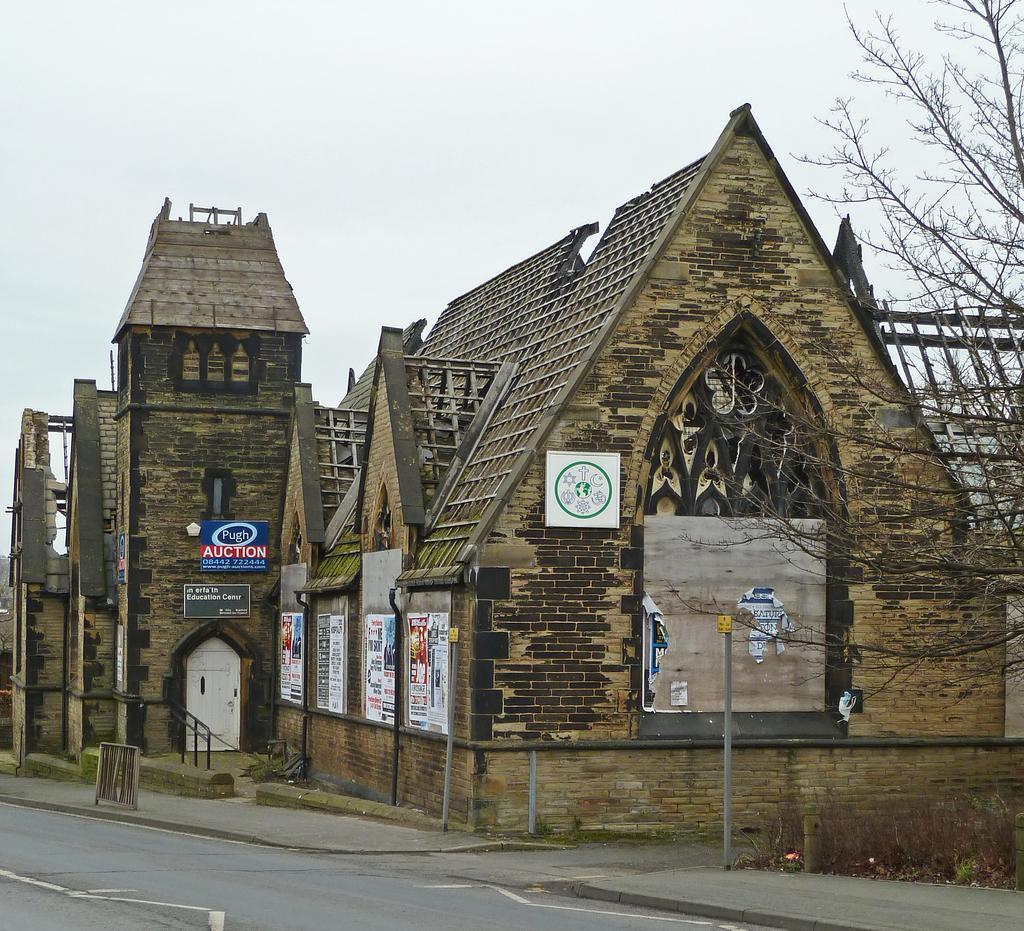Describe this image in one or two sentences. In this picture we can see brown shed house. In the front we can see the road. On the right corner there is a dry tree. On the top we can see the sky. 